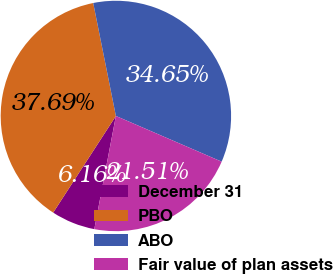Convert chart. <chart><loc_0><loc_0><loc_500><loc_500><pie_chart><fcel>December 31<fcel>PBO<fcel>ABO<fcel>Fair value of plan assets<nl><fcel>6.16%<fcel>37.69%<fcel>34.65%<fcel>21.51%<nl></chart> 